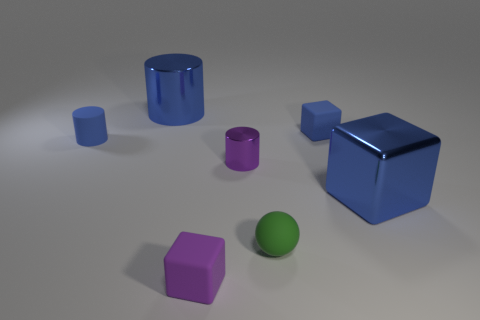The large object that is the same color as the big metallic cube is what shape?
Give a very brief answer. Cylinder. What color is the metal block?
Your answer should be very brief. Blue. Is the color of the small metal object the same as the rubber ball?
Your answer should be compact. No. How many big things have the same color as the metallic cube?
Your answer should be very brief. 1. What is the size of the purple object that is in front of the purple object behind the large blue metal block?
Keep it short and to the point. Small. What is the shape of the small purple matte object?
Make the answer very short. Cube. There is a tiny cube behind the rubber ball; what material is it?
Give a very brief answer. Rubber. What color is the block in front of the large metallic object to the right of the large object that is to the left of the blue shiny cube?
Your response must be concise. Purple. The ball that is the same size as the blue matte cylinder is what color?
Offer a very short reply. Green. What number of shiny objects are large red balls or large blue blocks?
Keep it short and to the point. 1. 